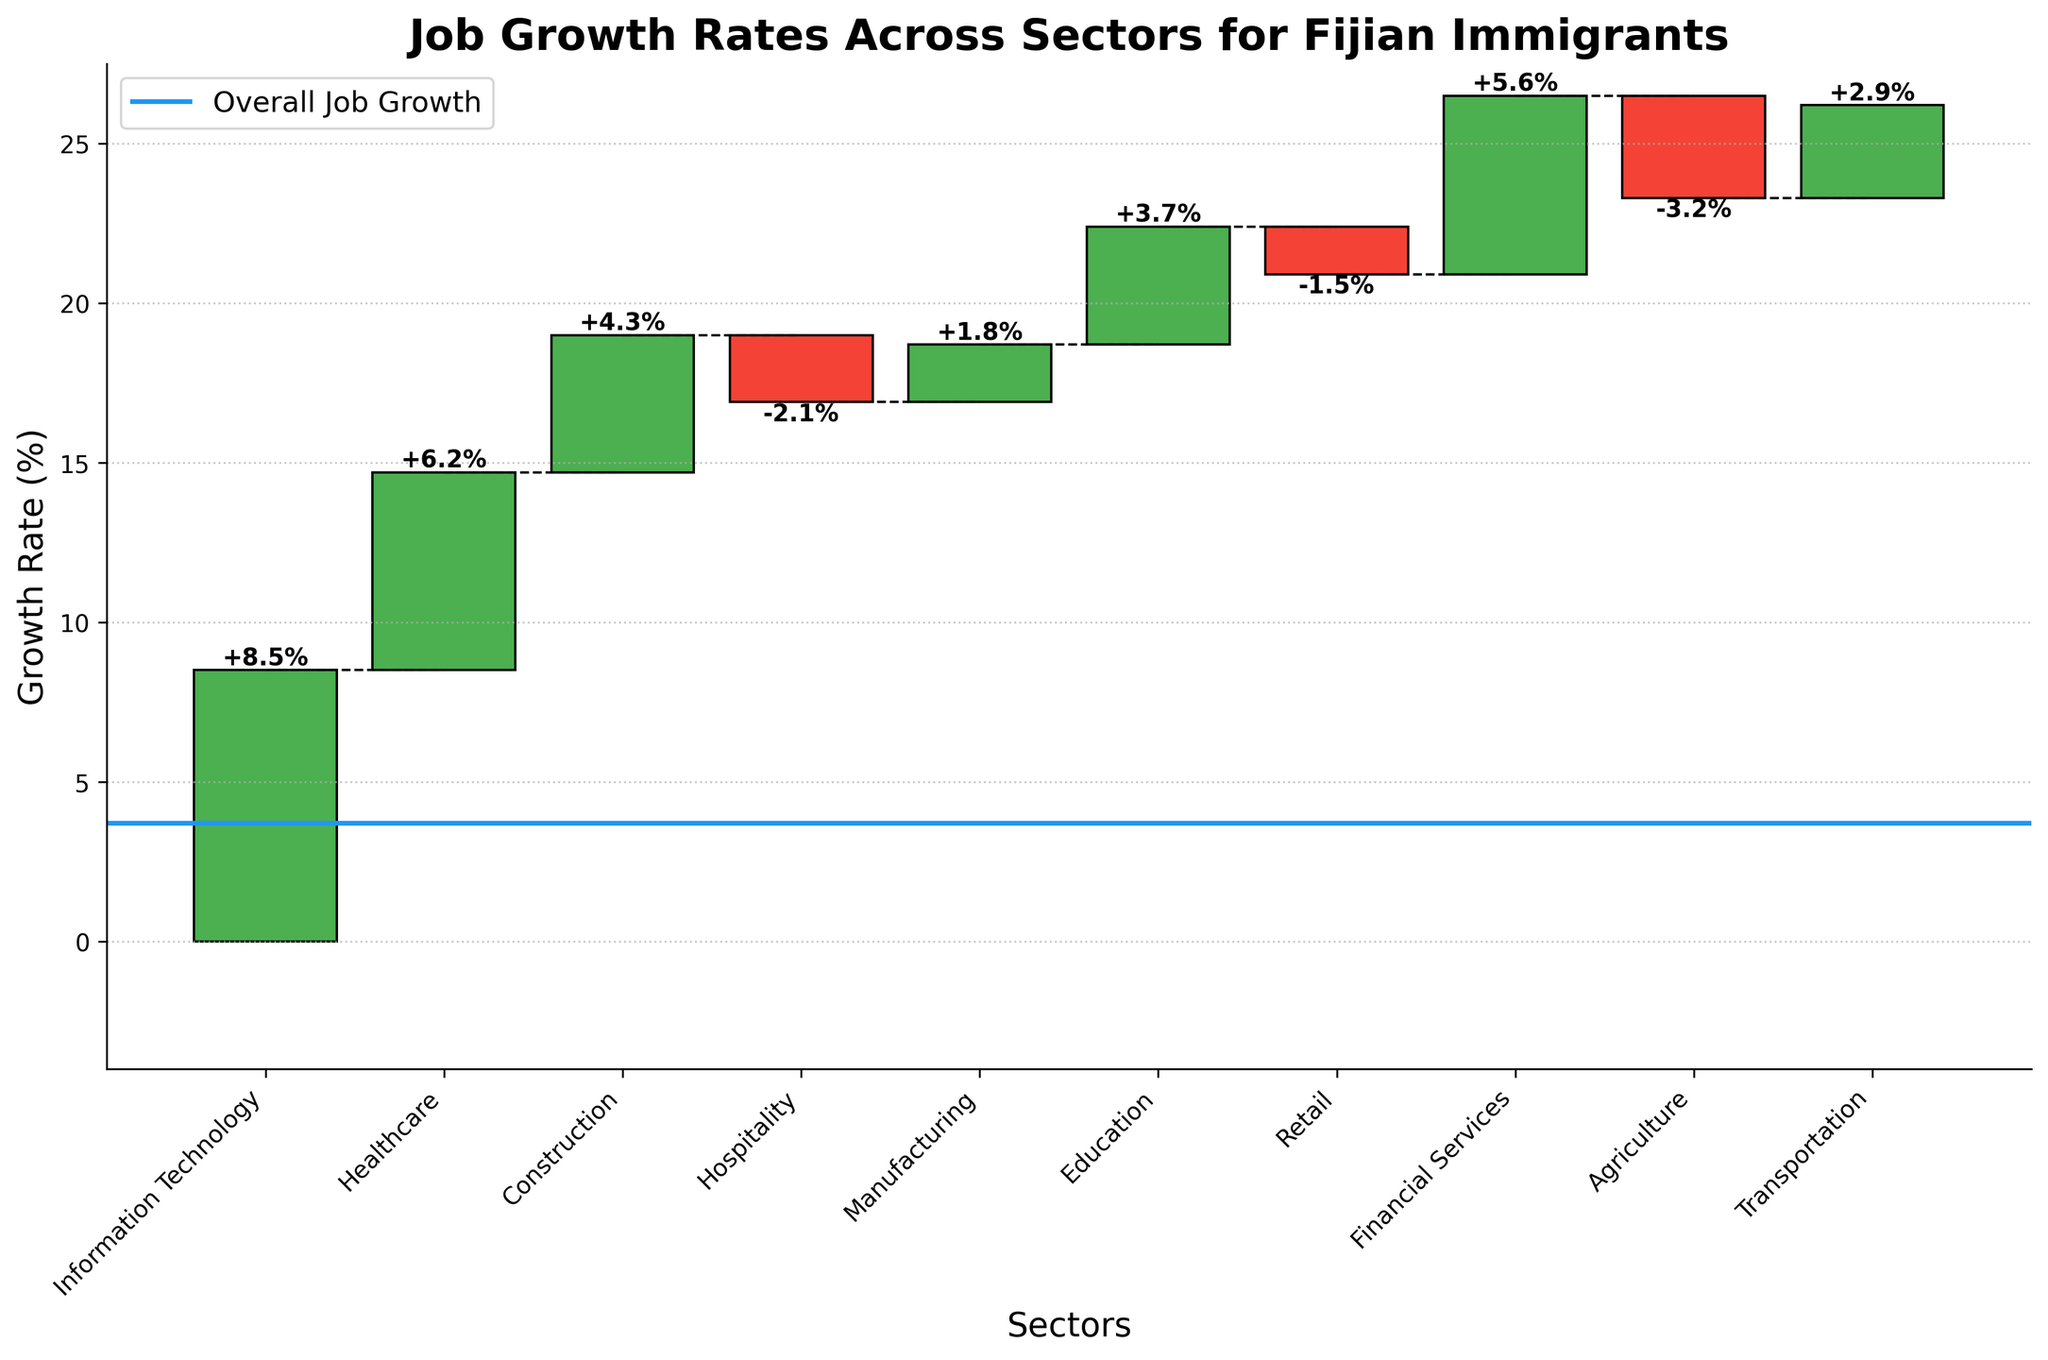What does the blue line represent on the chart? The blue line represents the "Overall Job Growth" rate, which is a marker showing the overall percentage growth across all sectors in the new city.
Answer: Overall Job Growth Which sector has the highest growth rate? The Information Technology sector shows the highest growth rate among all sectors as depicted by the tallest green bar pointing upwards.
Answer: Information Technology How many sectors have negative growth rates and which are they? To find sectors with negative growth rates, look for red bars pointing downwards. The sectors with such bars are Hospitality, Retail, and Agriculture.
Answer: 3 sectors: Hospitality, Retail, Agriculture By how much does the growth rate of Financial Services surpass that of Transportation? The growth rate of Financial Services is 5.6%, and the growth rate of Transportation is 2.9%. Subtract the latter from the former: 5.6% - 2.9% = 2.7%.
Answer: 2.7% What is the combined growth rate of Healthcare and Education sectors? The growth rate for Healthcare is 6.2%, and for Education, it is 3.7%. Adding these together: 6.2% + 3.7% = 9.9%.
Answer: 9.9% Which sector displays the least growth, and what is the percentage? The sector with the least growth is Agriculture, identified by the lowest red bar pointing downwards, with a growth rate of -3.2%.
Answer: Agriculture, -3.2% What is the difference in growth rates between the highest and lowest growing sectors? Information Technology has the highest growth rate at 8.5%, while Agriculture has the lowest at -3.2%. The difference is 8.5% - (-3.2%) = 11.7%.
Answer: 11.7% What is the overall impact of the negative growth sectors on the job growth rate? Identify the sectors with negative growth (Hospitality, Retail, Agriculture) and sum their growth rates: -2.1%, -1.5%, and -3.2%, respectively. The total negative impact is -2.1 + (-1.5) + (-3.2) = -6.8%.
Answer: -6.8% Based on the chart, which sector should Fijian immigrants particularly consider for job opportunities based on growth rate trends? Fijian immigrants should consider sectors with high positive growth rates. Information Technology (8.5%) is the highest, followed by Healthcare (6.2%) and Financial Services (5.6%).
Answer: Information Technology What is the median growth rate of all sectors? Order the growth rates from sorted: -3.2, -2.1, -1.5, 1.8, 2.9, 3.7, 4.3, 5.6, 6.2, 8.5. The median is the middle value of an ordered list, which here is (3.7+4.3)/2 = 4.0%.
Answer: 4.0% 